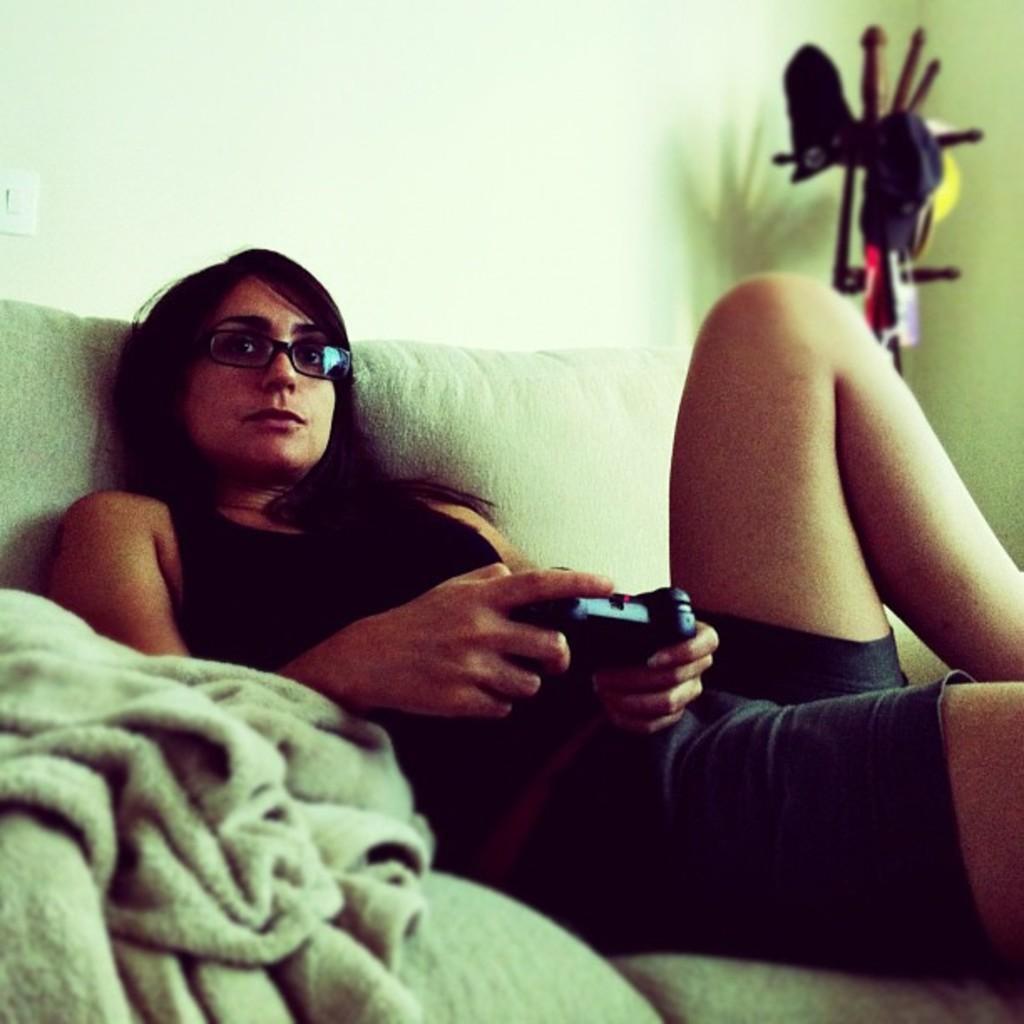Describe this image in one or two sentences. In this image we can see a woman wearing a black dress and spectacles is sitting on the sofa and holding a joystick in her hands. Here we can see the blanket. In the background, we can see stand where caps are hanged and switch board on the wall. 